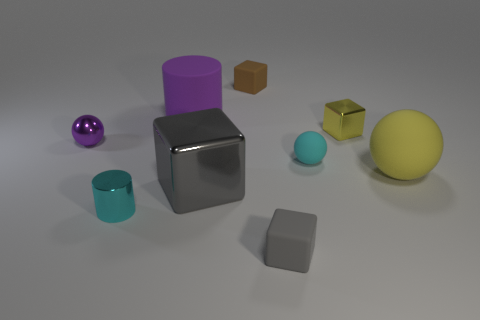This collection of objects seems like it could tell a story. What narrative could they represent? The variety of objects could symbolize the diversity of characters in a community. The robust silver cube might represent a strong, foundational character, while the bright yellow sphere could symbolize a sunny personality. Together, they weave a narrative of cohesion despite individual differences, much like the members of a well-rounded society. 